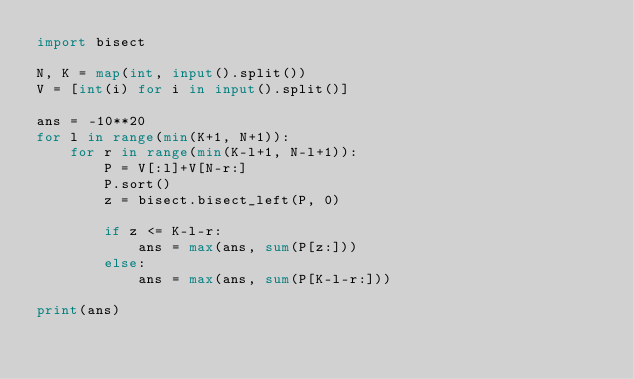Convert code to text. <code><loc_0><loc_0><loc_500><loc_500><_Python_>import bisect

N, K = map(int, input().split())
V = [int(i) for i in input().split()]

ans = -10**20
for l in range(min(K+1, N+1)):
    for r in range(min(K-l+1, N-l+1)):
        P = V[:l]+V[N-r:]
        P.sort()
        z = bisect.bisect_left(P, 0)

        if z <= K-l-r:
            ans = max(ans, sum(P[z:]))
        else:
            ans = max(ans, sum(P[K-l-r:]))

print(ans)
</code> 